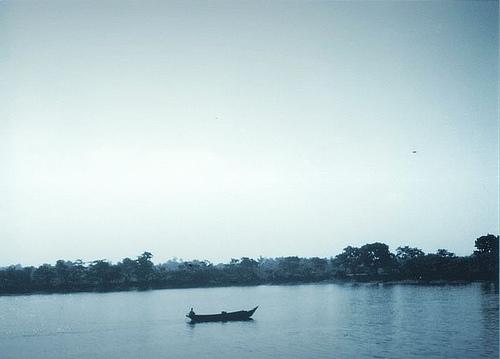Why is the boat stopped?
Answer briefly. Fishing. Is there animals in this picture?
Answer briefly. No. What color is the canoe?
Keep it brief. Black. Is there a walkway where people can stand?
Answer briefly. No. Is this a resort?
Answer briefly. No. What is in the water?
Answer briefly. Boat. What body of water is this boat fishing on?
Write a very short answer. Lake. What is the condition of the water?
Give a very brief answer. Calm. What time of day is it?
Write a very short answer. Morning. 